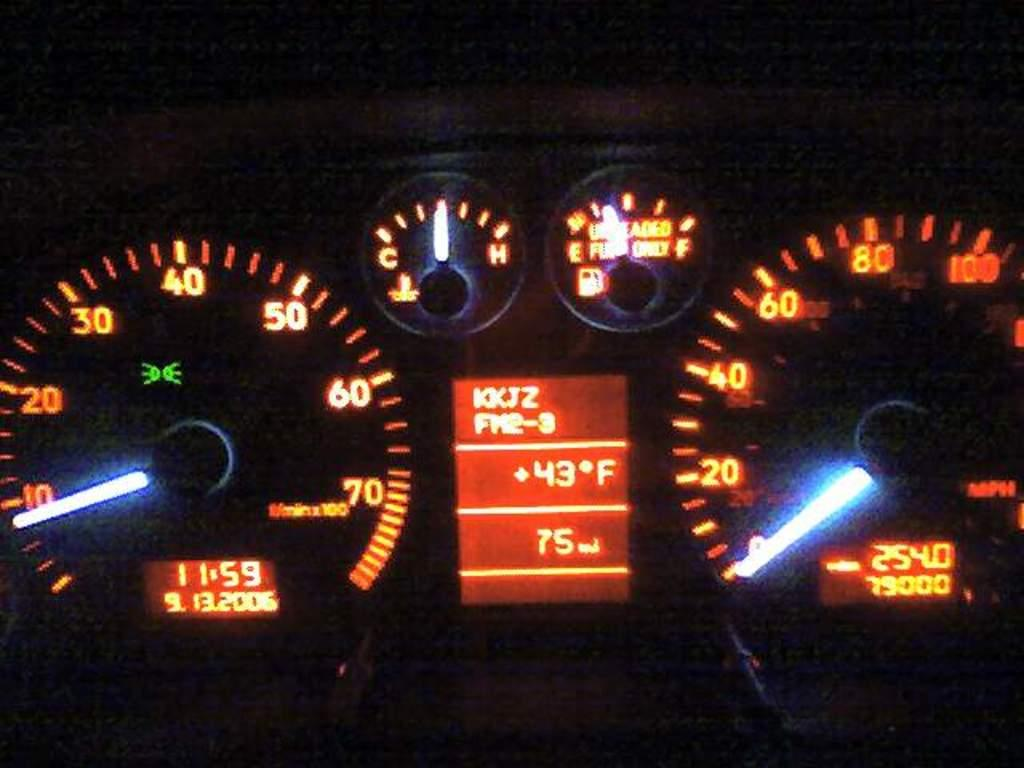What type of instruments are present in the image? There are tachometers in the image. Can you describe the background of the image? The background of the image is dark. What type of meat is being prepared by your dad in the image? There is no meat or dad present in the image; it only features tachometers and a dark background. 